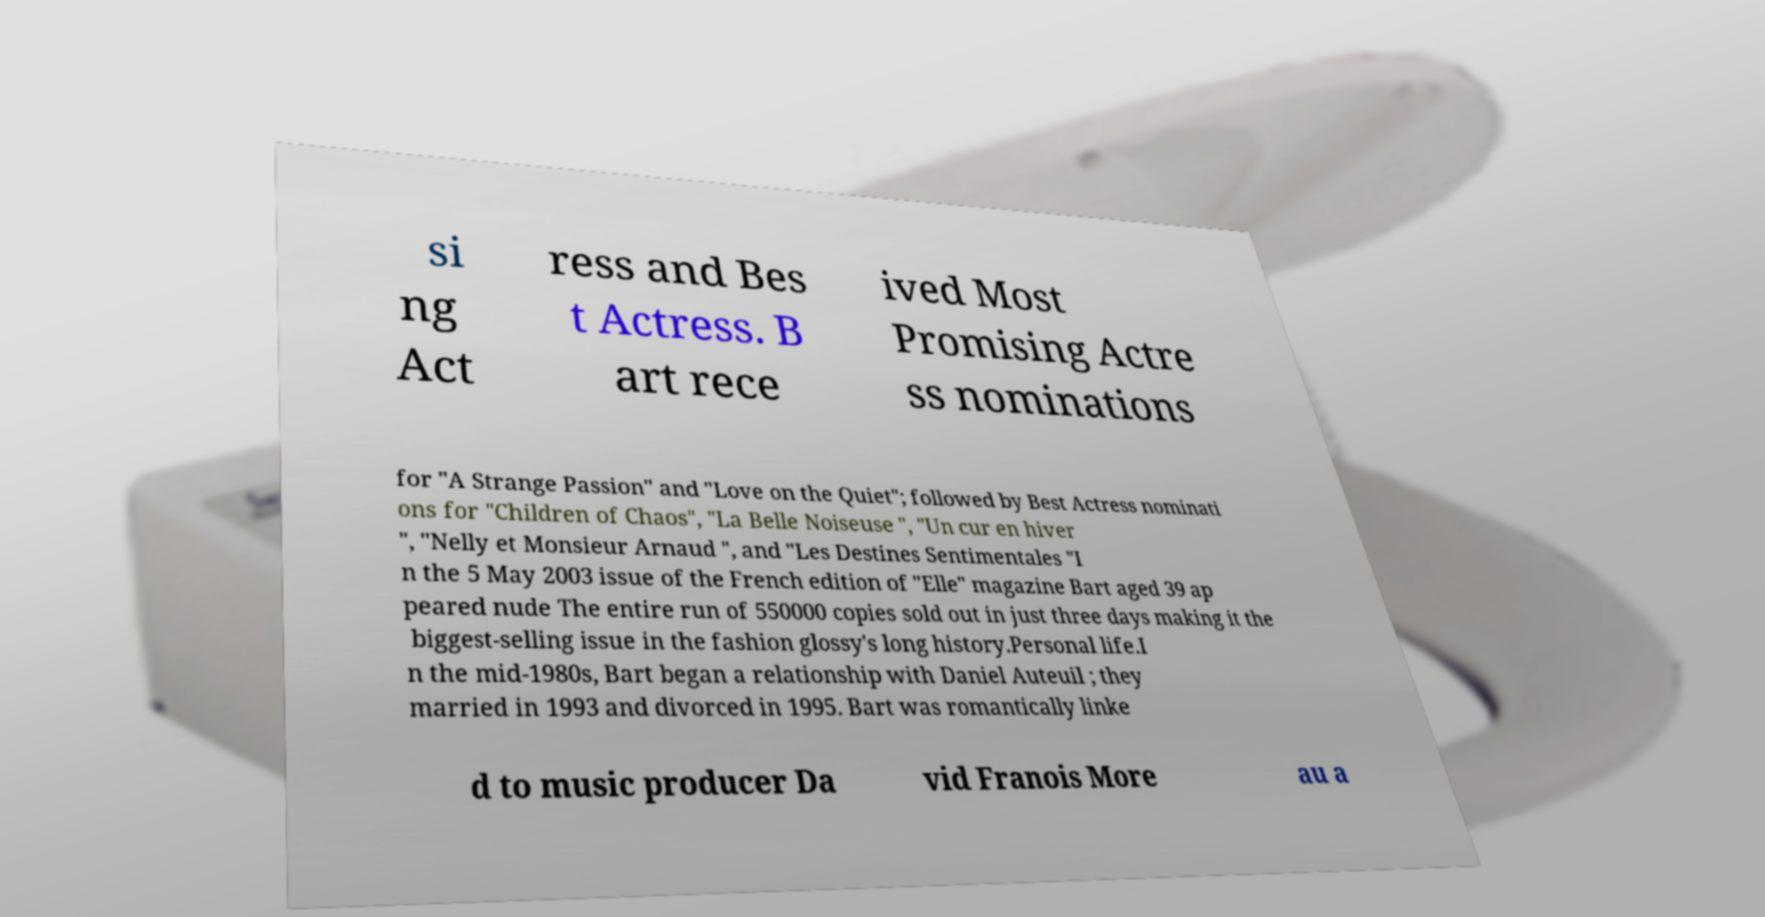Please read and relay the text visible in this image. What does it say? si ng Act ress and Bes t Actress. B art rece ived Most Promising Actre ss nominations for "A Strange Passion" and "Love on the Quiet"; followed by Best Actress nominati ons for "Children of Chaos", "La Belle Noiseuse ", "Un cur en hiver ", "Nelly et Monsieur Arnaud ", and "Les Destines Sentimentales "I n the 5 May 2003 issue of the French edition of "Elle" magazine Bart aged 39 ap peared nude The entire run of 550000 copies sold out in just three days making it the biggest-selling issue in the fashion glossy's long history.Personal life.I n the mid-1980s, Bart began a relationship with Daniel Auteuil ; they married in 1993 and divorced in 1995. Bart was romantically linke d to music producer Da vid Franois More au a 